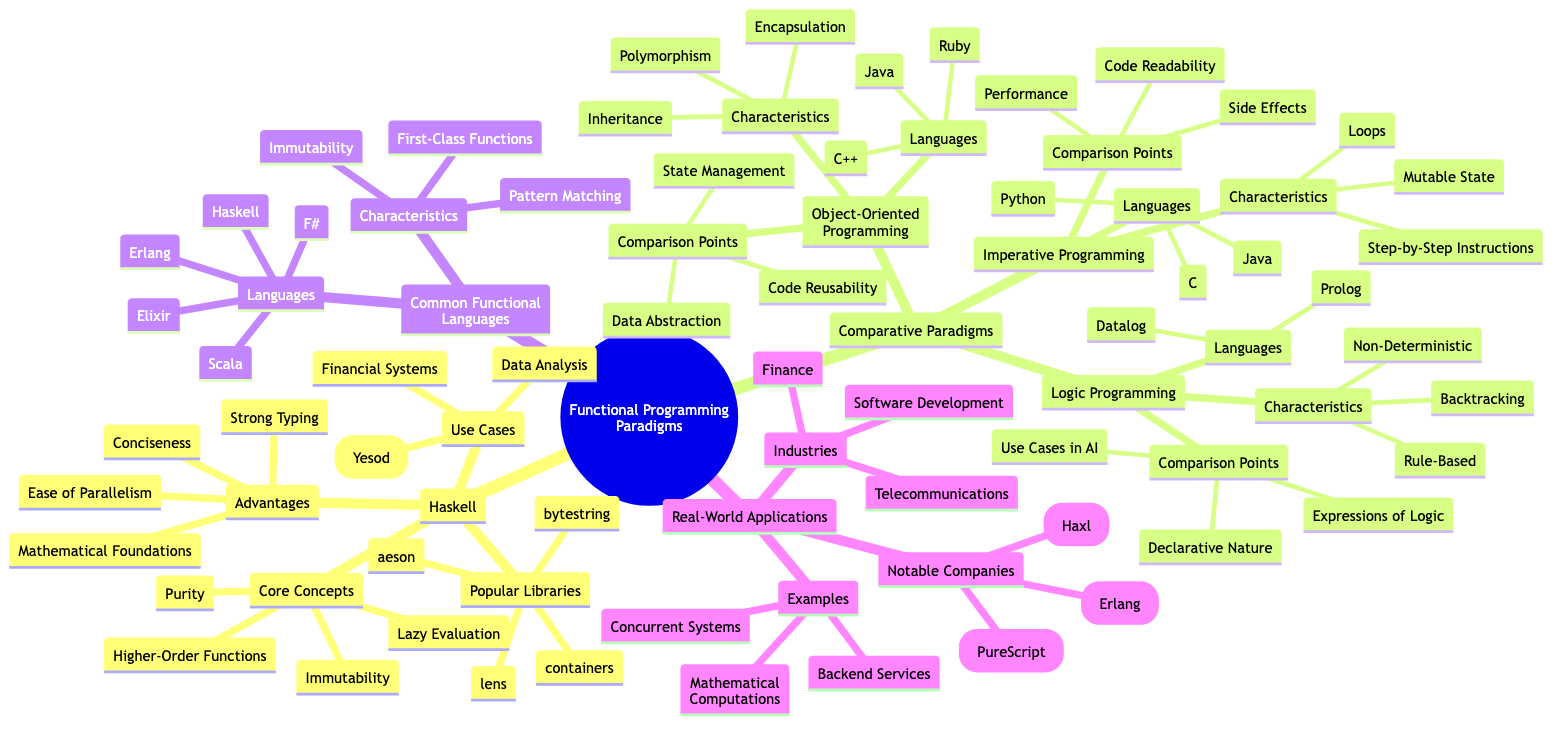What's one core concept of Haskell? The diagram lists four core concepts under Haskell, one of which is "Purity."
Answer: Purity Which functional language is commonly used in finance? According to the Real-World Applications section, "Finance" is listed as one of the industries where functional languages, including Haskell, are applied.
Answer: Haskell What are two comparison points in imperative programming? The diagram indicates three comparison points for imperative programming, one of which is "Side Effects," and another is "Code Readability."
Answer: Side Effects, Code Readability How many languages are listed under Object-Oriented Programming? The diagram shows that there are three languages listed under Object-Oriented Programming: "Java," "C++," and "Ruby." Thus, the total count is three.
Answer: 3 What characteristic is common among functional languages? The Common Functional Languages section lists several characteristics, with "Immutability" being one of them.
Answer: Immutability Which libraries are popular in Haskell? The Popular Libraries section under Haskell indicates four libraries, one of which is "lens."
Answer: lens What type of programming uses rule-based characteristics? The Logic Programming section describes its characteristics, with one of them being "Rule-Based."
Answer: Logic Programming What is a common use case for functional programming in web development? Web Development (Yesod) is explicitly mentioned as a use case within the Haskell section of the diagram.
Answer: Web Development (Yesod) Which notable company uses Erlang? The Real-World Applications section lists "WhatsApp (Erlang)" as a notable company using Erlang.
Answer: WhatsApp (Erlang) 